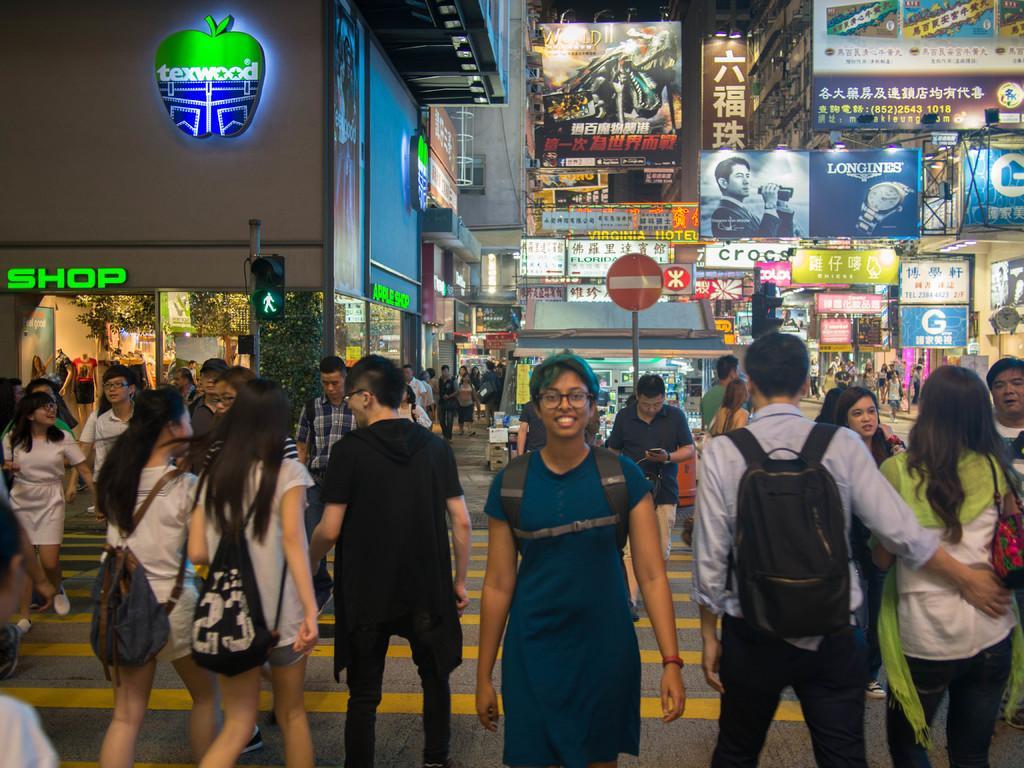Can you describe this image briefly? In this image I can see the group of people walking on the road. These people are wearing the different color dresses and few people with the bags. In the background I can see many boards attached to the building. These boards are colorful. I can also see the tree to the left. 